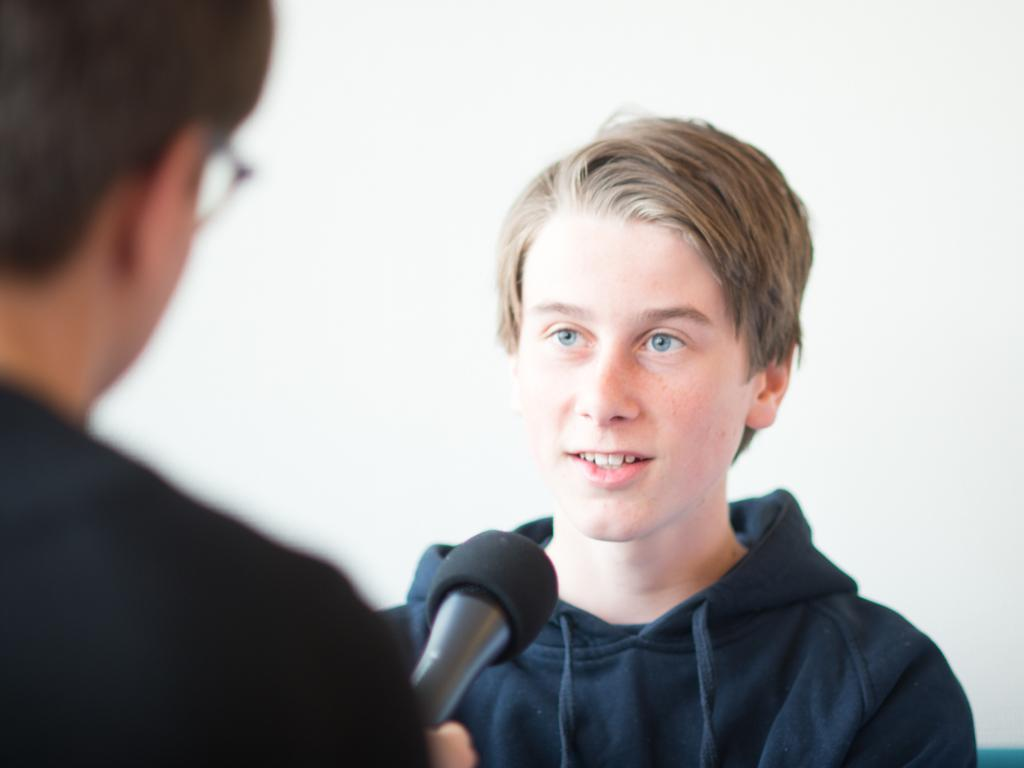How many people are in the image? There are two persons in the image. What is one person wearing? One person is wearing a sweater. What is the person wearing a sweater holding? The person wearing a sweater is holding a microphone. What type of string can be seen tied around the person's body in the image? There is no string tied around any person's body in the image. What kind of lock is visible on the person's clothing in the image? There is no lock visible on any person's clothing in the image. 